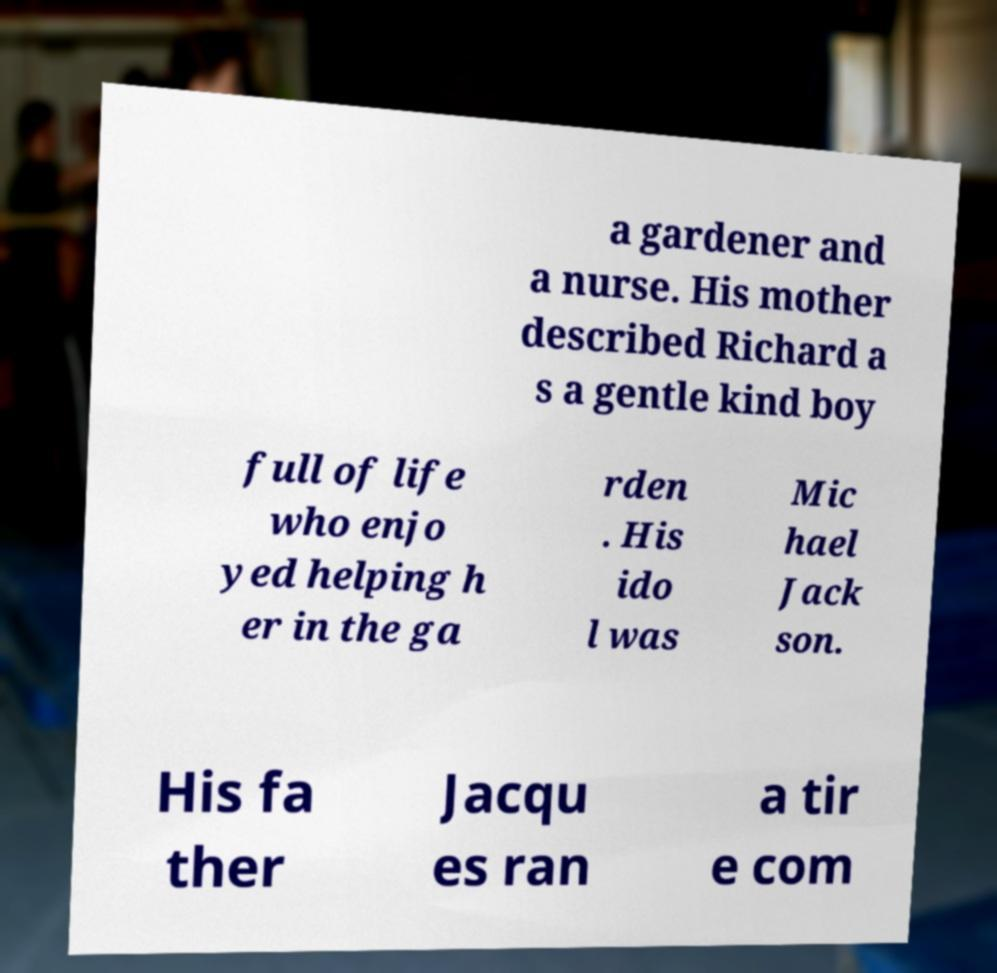Can you accurately transcribe the text from the provided image for me? a gardener and a nurse. His mother described Richard a s a gentle kind boy full of life who enjo yed helping h er in the ga rden . His ido l was Mic hael Jack son. His fa ther Jacqu es ran a tir e com 